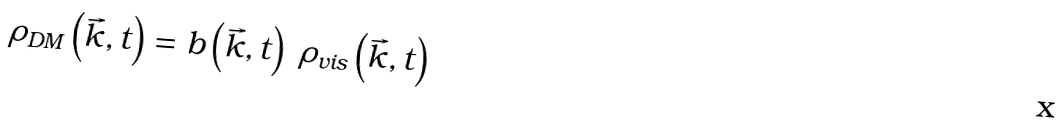<formula> <loc_0><loc_0><loc_500><loc_500>\rho _ { D M } \left ( \vec { k } , t \right ) = b \left ( \vec { k } , t \right ) \ \rho _ { v i s } \left ( \vec { k } , t \right )</formula> 